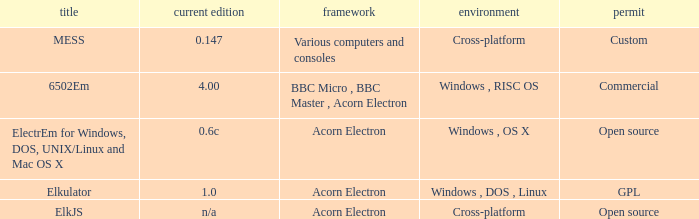What is the system called that is named ELKJS? Acorn Electron. 